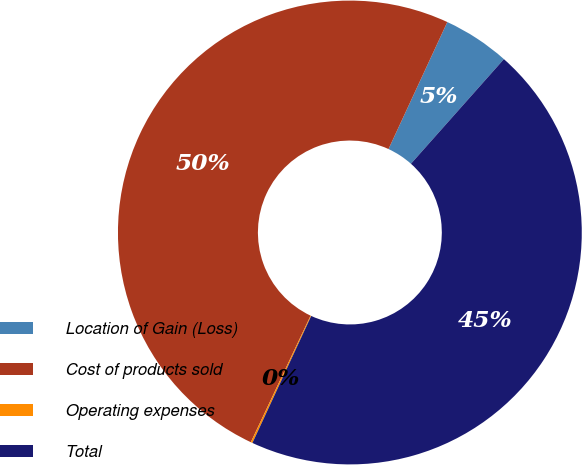<chart> <loc_0><loc_0><loc_500><loc_500><pie_chart><fcel>Location of Gain (Loss)<fcel>Cost of products sold<fcel>Operating expenses<fcel>Total<nl><fcel>4.66%<fcel>49.88%<fcel>0.12%<fcel>45.34%<nl></chart> 